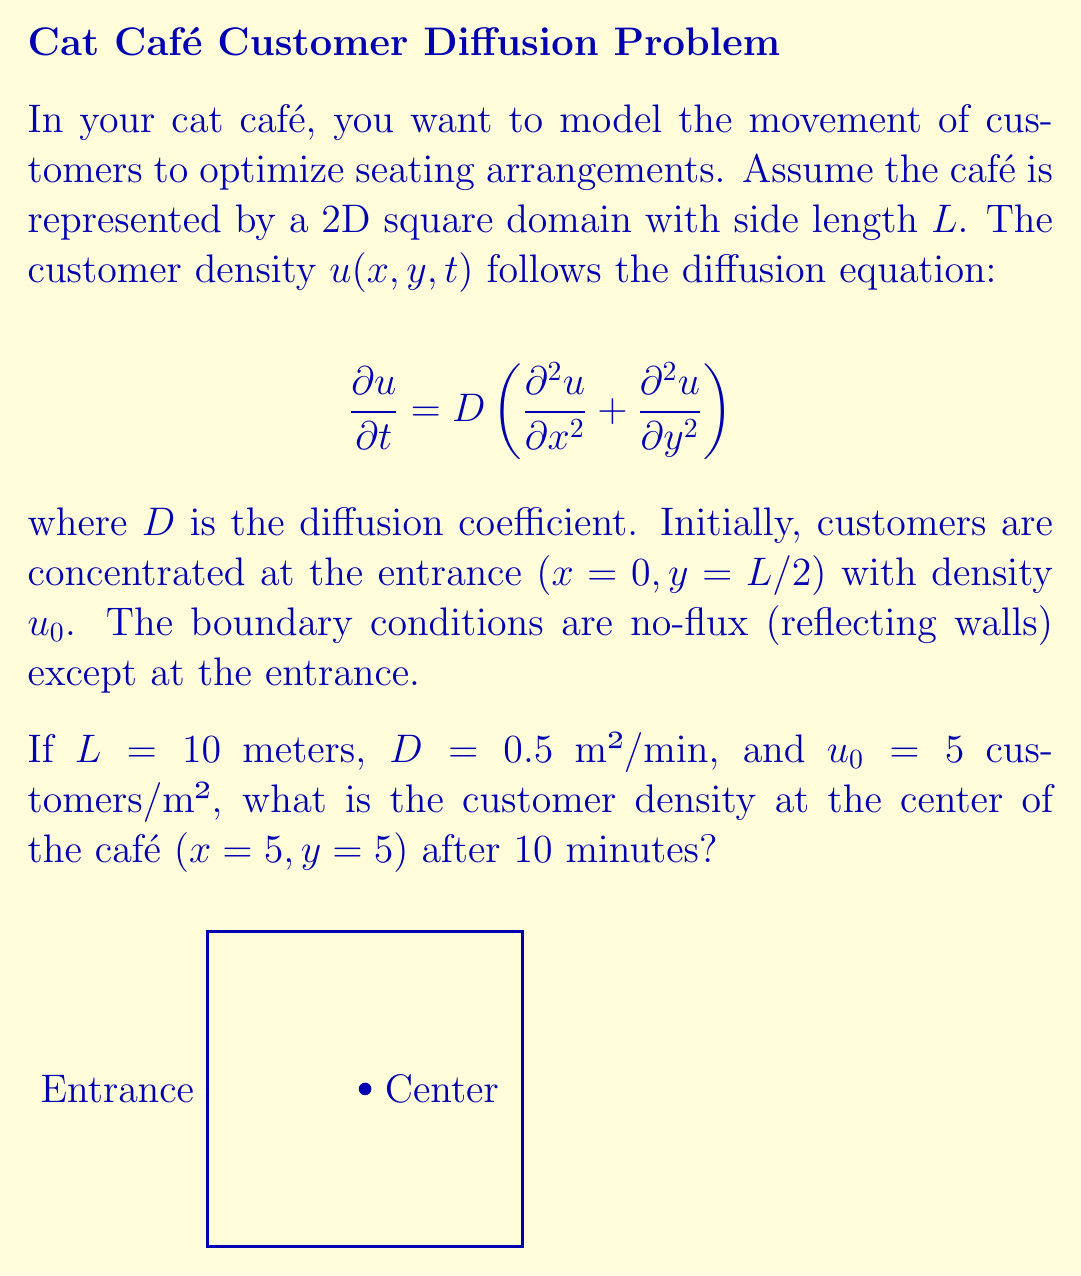Show me your answer to this math problem. To solve this problem, we need to use the solution to the 2D diffusion equation with a point source. The solution is given by:

$$u(x,y,t) = \frac{u_0}{4\pi Dt} \exp\left(-\frac{(x-x_0)^2 + (y-y_0)^2}{4Dt}\right)$$

Where (x₀, y₀) is the initial source location.

Steps:
1. Identify the parameters:
   L = 10 m
   D = 0.5 m²/min
   u₀ = 5 customers/m²
   t = 10 min
   (x, y) = (5, 5) m (center of café)
   (x₀, y₀) = (0, 5) m (entrance)

2. Substitute the values into the equation:
   $$u(5,5,10) = \frac{5}{4\pi(0.5)(10)} \exp\left(-\frac{(5-0)^2 + (5-5)^2}{4(0.5)(10)}\right)$$

3. Simplify:
   $$u(5,5,10) = \frac{5}{20\pi} \exp\left(-\frac{25}{20}\right)$$

4. Calculate:
   $$u(5,5,10) \approx 0.0398 \text{ customers/m²}$$

Note: The actual solution would involve considering reflections from the walls, which would increase the density slightly. This simplified solution gives a lower bound for the density at the center.
Answer: 0.0398 customers/m² 